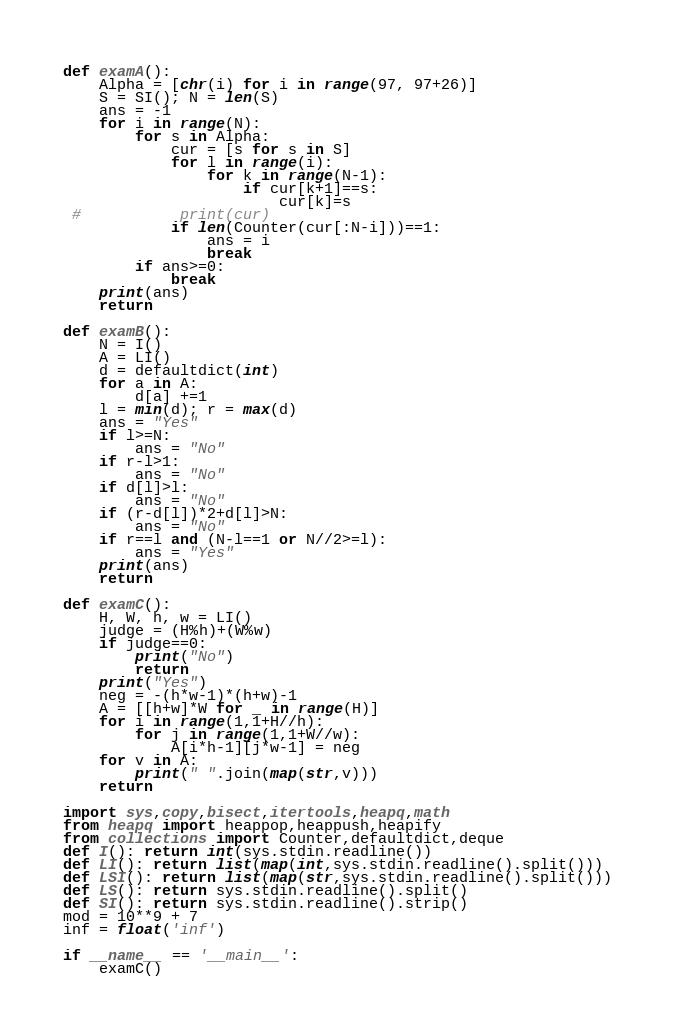Convert code to text. <code><loc_0><loc_0><loc_500><loc_500><_Python_>def examA():
    Alpha = [chr(i) for i in range(97, 97+26)]
    S = SI(); N = len(S)
    ans = -1
    for i in range(N):
        for s in Alpha:
            cur = [s for s in S]
            for l in range(i):
                for k in range(N-1):
                    if cur[k+1]==s:
                        cur[k]=s
 #           print(cur)
            if len(Counter(cur[:N-i]))==1:
                ans = i
                break
        if ans>=0:
            break
    print(ans)
    return

def examB():
    N = I()
    A = LI()
    d = defaultdict(int)
    for a in A:
        d[a] +=1
    l = min(d); r = max(d)
    ans = "Yes"
    if l>=N:
        ans = "No"
    if r-l>1:
        ans = "No"
    if d[l]>l:
        ans = "No"
    if (r-d[l])*2+d[l]>N:
        ans = "No"
    if r==l and (N-l==1 or N//2>=l):
        ans = "Yes"
    print(ans)
    return

def examC():
    H, W, h, w = LI()
    judge = (H%h)+(W%w)
    if judge==0:
        print("No")
        return
    print("Yes")
    neg = -(h*w-1)*(h+w)-1
    A = [[h+w]*W for _ in range(H)]
    for i in range(1,1+H//h):
        for j in range(1,1+W//w):
            A[i*h-1][j*w-1] = neg
    for v in A:
        print(" ".join(map(str,v)))
    return

import sys,copy,bisect,itertools,heapq,math
from heapq import heappop,heappush,heapify
from collections import Counter,defaultdict,deque
def I(): return int(sys.stdin.readline())
def LI(): return list(map(int,sys.stdin.readline().split()))
def LSI(): return list(map(str,sys.stdin.readline().split()))
def LS(): return sys.stdin.readline().split()
def SI(): return sys.stdin.readline().strip()
mod = 10**9 + 7
inf = float('inf')

if __name__ == '__main__':
    examC()
</code> 